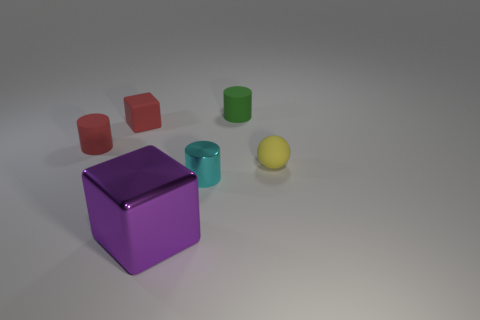Is there any other thing that has the same size as the purple block?
Your answer should be very brief. No. How many objects are green rubber cylinders or red matte things?
Keep it short and to the point. 3. Do the metal object that is on the left side of the tiny shiny cylinder and the tiny thing in front of the tiny ball have the same shape?
Give a very brief answer. No. The metallic thing on the left side of the tiny metallic cylinder has what shape?
Make the answer very short. Cube. Is the number of red things that are in front of the red matte block the same as the number of small metallic objects behind the green object?
Give a very brief answer. No. What number of objects are either tiny gray blocks or small objects that are behind the tiny rubber sphere?
Keep it short and to the point. 3. There is a thing that is in front of the rubber block and to the left of the large purple block; what shape is it?
Offer a terse response. Cylinder. The tiny thing that is to the right of the matte cylinder to the right of the large metallic cube is made of what material?
Your answer should be very brief. Rubber. Is the material of the small green thing left of the yellow matte ball the same as the red block?
Your answer should be compact. Yes. There is a block behind the tiny yellow rubber sphere; what is its size?
Ensure brevity in your answer.  Small. 